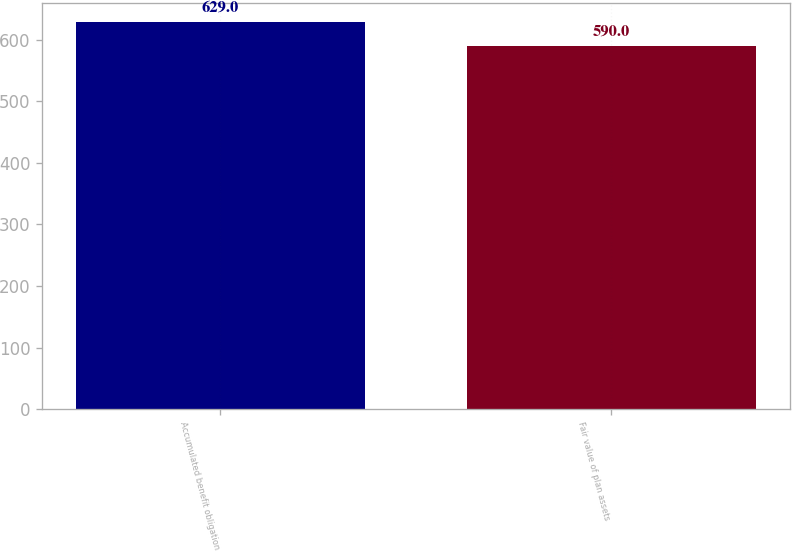<chart> <loc_0><loc_0><loc_500><loc_500><bar_chart><fcel>Accumulated benefit obligation<fcel>Fair value of plan assets<nl><fcel>629<fcel>590<nl></chart> 